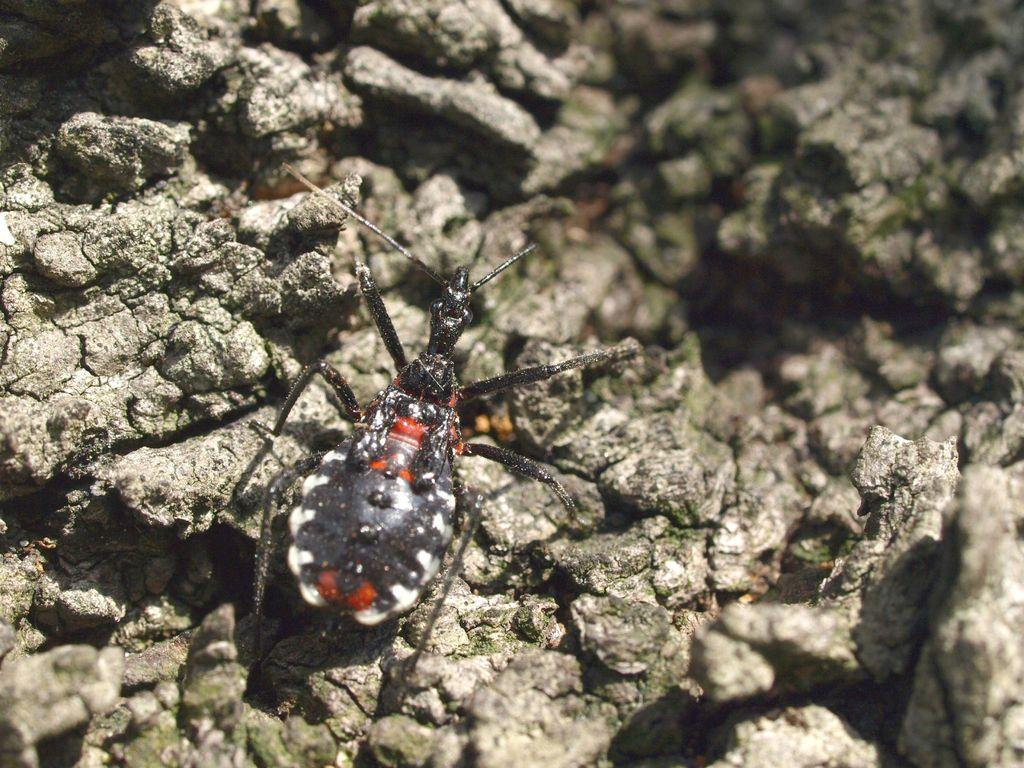What type of creature can be seen in the image? There is an insect in the image. What is the insect's location in the image? The insect is on a rocky surface. What type of oven is visible in the image? There is no oven present in the image; it features an insect on a rocky surface. How does the insect rub its legs together in the image? The image does not show the insect rubbing its legs together; it only shows the insect on a rocky surface. 